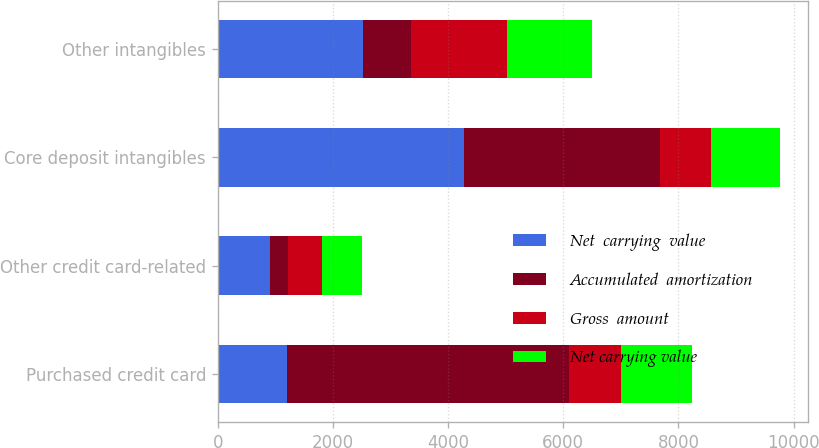Convert chart to OTSL. <chart><loc_0><loc_0><loc_500><loc_500><stacked_bar_chart><ecel><fcel>Purchased credit card<fcel>Other credit card-related<fcel>Core deposit intangibles<fcel>Other intangibles<nl><fcel>Net  carrying  value<fcel>1207<fcel>907<fcel>4280<fcel>2515<nl><fcel>Accumulated  amortization<fcel>4892<fcel>314<fcel>3401<fcel>845<nl><fcel>Gross  amount<fcel>897<fcel>593<fcel>879<fcel>1670<nl><fcel>Net carrying value<fcel>1246<fcel>691<fcel>1207<fcel>1477<nl></chart> 